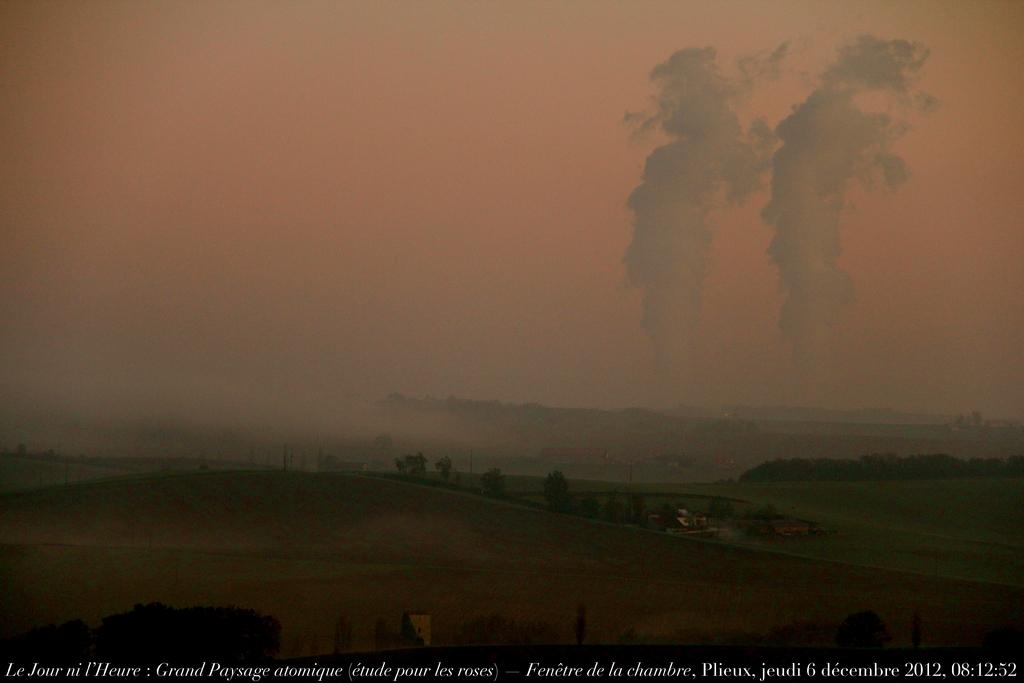What is the primary subject of the image? The image depicts a sky. What type of creature can be seen wearing a boot in the image? There is no creature or boot present in the image; it only depicts a sky. 